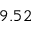Convert formula to latex. <formula><loc_0><loc_0><loc_500><loc_500>9 . 5 2</formula> 